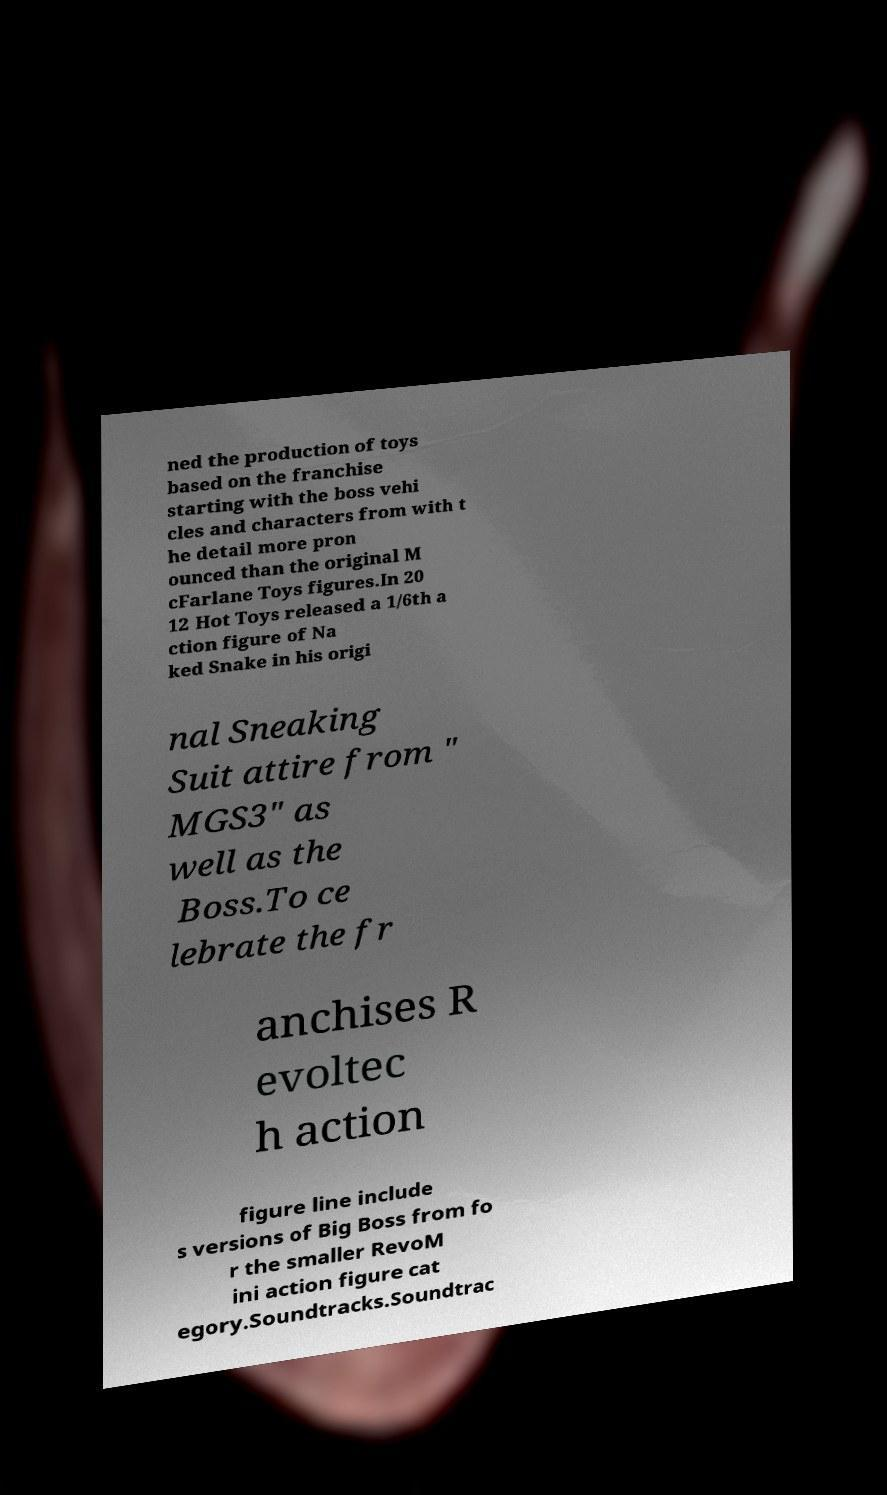What messages or text are displayed in this image? I need them in a readable, typed format. ned the production of toys based on the franchise starting with the boss vehi cles and characters from with t he detail more pron ounced than the original M cFarlane Toys figures.In 20 12 Hot Toys released a 1/6th a ction figure of Na ked Snake in his origi nal Sneaking Suit attire from " MGS3" as well as the Boss.To ce lebrate the fr anchises R evoltec h action figure line include s versions of Big Boss from fo r the smaller RevoM ini action figure cat egory.Soundtracks.Soundtrac 